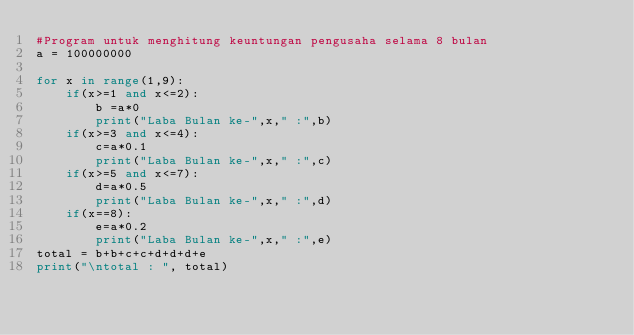<code> <loc_0><loc_0><loc_500><loc_500><_Python_>#Program untuk menghitung keuntungan pengusaha selama 8 bulan
a = 100000000

for x in range(1,9):
    if(x>=1 and x<=2):
        b =a*0
        print("Laba Bulan ke-",x," :",b)
    if(x>=3 and x<=4):
        c=a*0.1
        print("Laba Bulan ke-",x," :",c)
    if(x>=5 and x<=7):
        d=a*0.5
        print("Laba Bulan ke-",x," :",d)
    if(x==8):
        e=a*0.2
        print("Laba Bulan ke-",x," :",e)
total = b+b+c+c+d+d+d+e
print("\ntotal : ", total)
</code> 